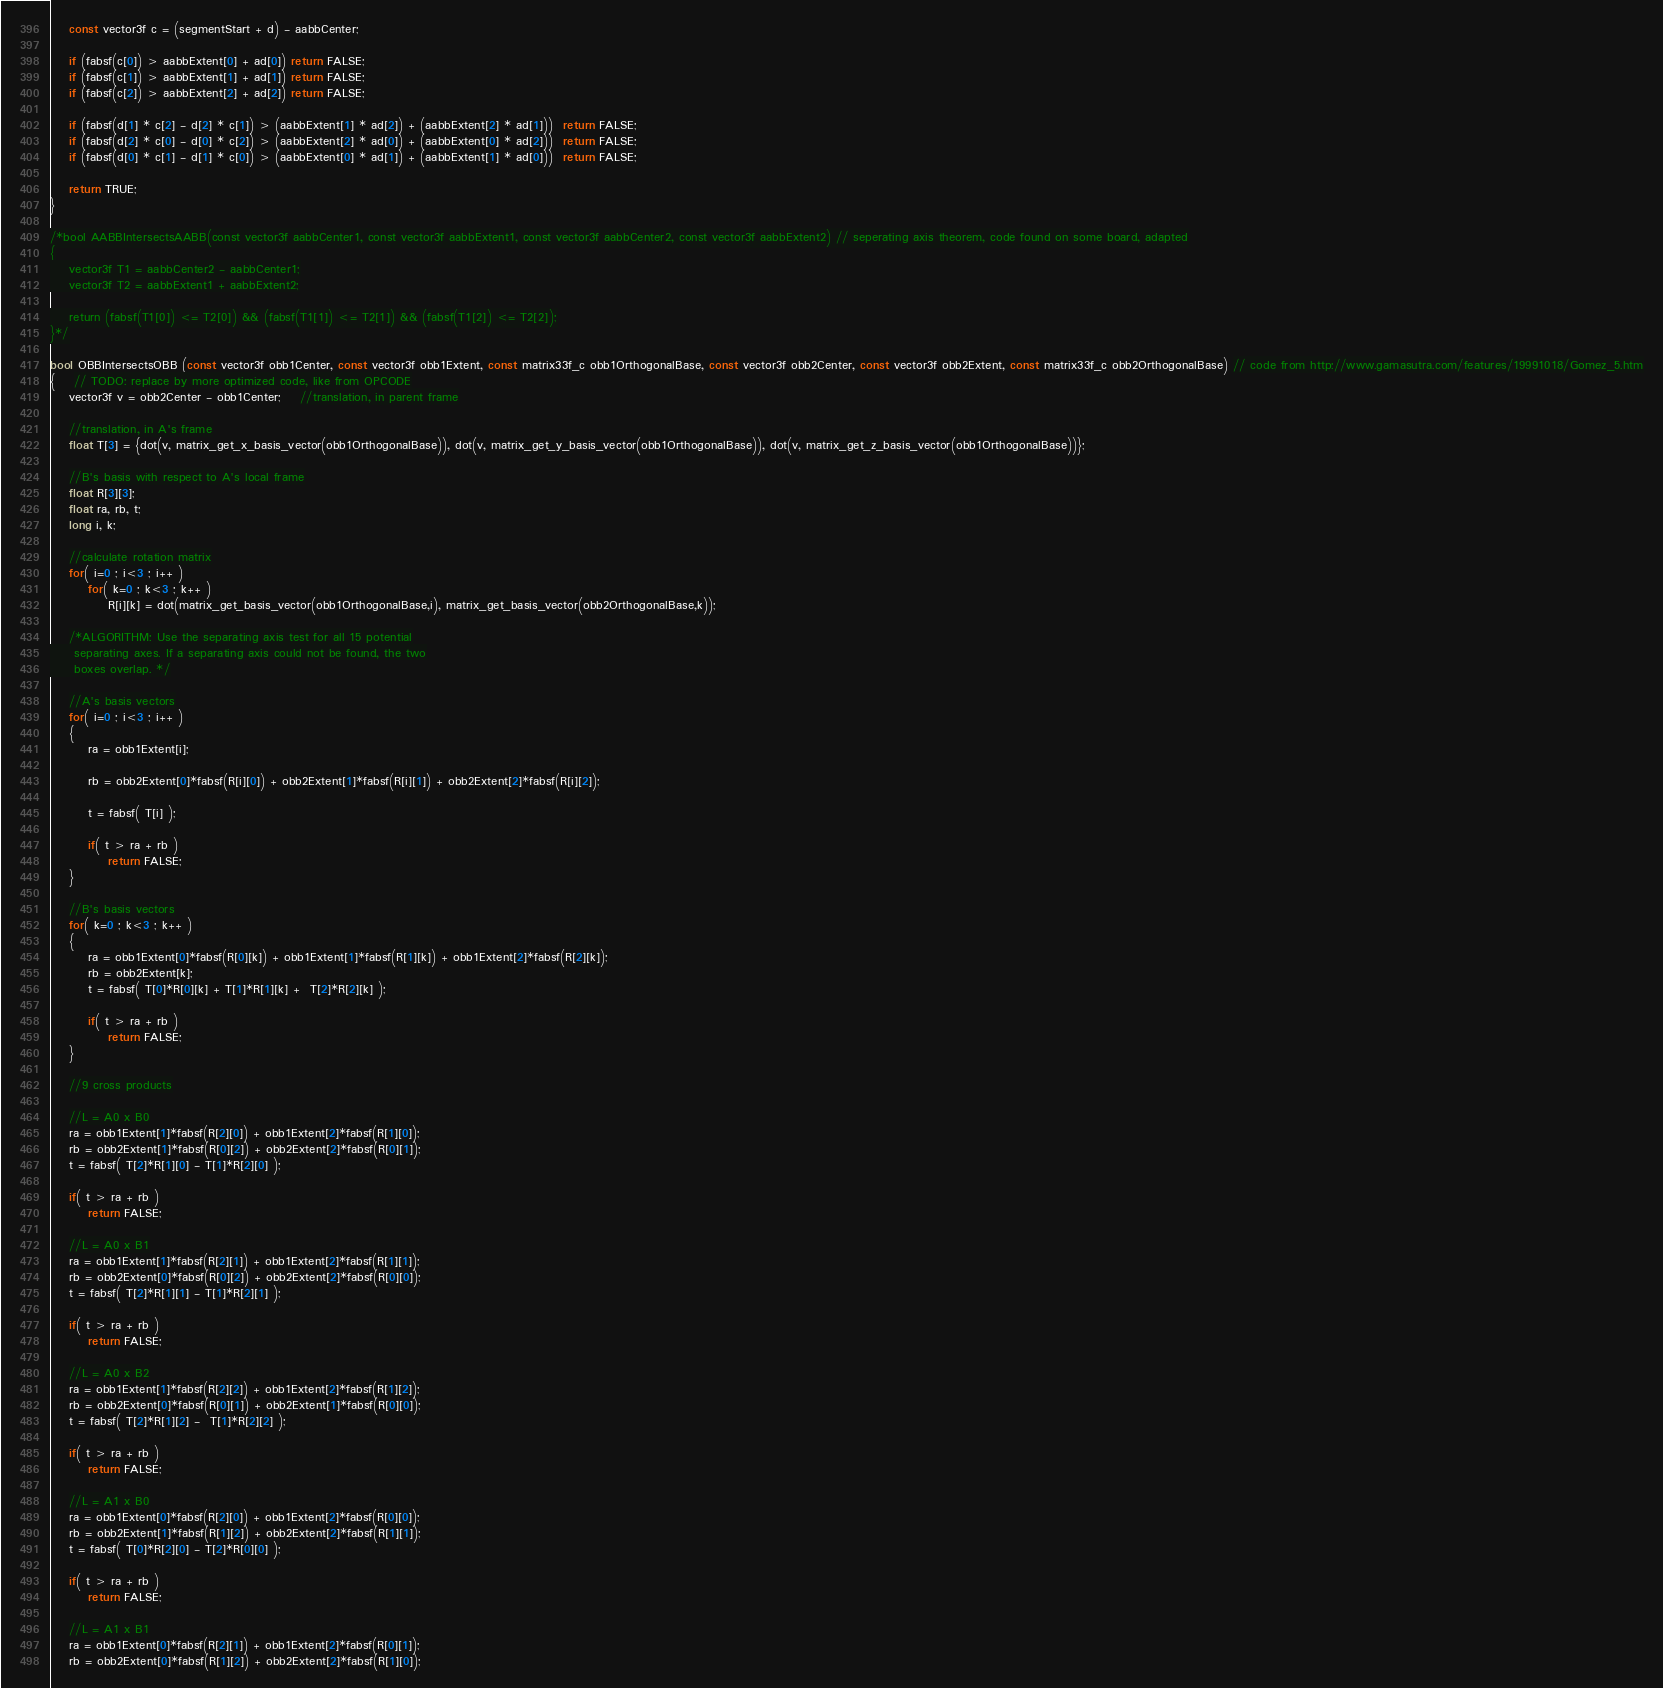<code> <loc_0><loc_0><loc_500><loc_500><_ObjectiveC_>	const vector3f c = (segmentStart + d) - aabbCenter;

    if (fabsf(c[0]) > aabbExtent[0] + ad[0]) return FALSE;
    if (fabsf(c[1]) > aabbExtent[1] + ad[1]) return FALSE;
    if (fabsf(c[2]) > aabbExtent[2] + ad[2]) return FALSE;

    if (fabsf(d[1] * c[2] - d[2] * c[1]) > (aabbExtent[1] * ad[2]) + (aabbExtent[2] * ad[1]))  return FALSE;
    if (fabsf(d[2] * c[0] - d[0] * c[2]) > (aabbExtent[2] * ad[0]) + (aabbExtent[0] * ad[2]))  return FALSE;
    if (fabsf(d[0] * c[1] - d[1] * c[0]) > (aabbExtent[0] * ad[1]) + (aabbExtent[1] * ad[0]))  return FALSE;

    return TRUE;
}

/*bool AABBIntersectsAABB(const vector3f aabbCenter1, const vector3f aabbExtent1, const vector3f aabbCenter2, const vector3f aabbExtent2) // seperating axis theorem, code found on some board, adapted
{
	vector3f T1 = aabbCenter2 - aabbCenter1;
	vector3f T2 = aabbExtent1 + aabbExtent2;

	return (fabsf(T1[0]) <= T2[0]) && (fabsf(T1[1]) <= T2[1]) && (fabsf(T1[2]) <= T2[2]);
}*/

bool OBBIntersectsOBB (const vector3f obb1Center, const vector3f obb1Extent, const matrix33f_c obb1OrthogonalBase, const vector3f obb2Center, const vector3f obb2Extent, const matrix33f_c obb2OrthogonalBase) // code from http://www.gamasutra.com/features/19991018/Gomez_5.htm
{	// TODO: replace by more optimized code, like from OPCODE
	vector3f v = obb2Center - obb1Center; 	//translation, in parent frame

	//translation, in A's frame
	float T[3] = {dot(v, matrix_get_x_basis_vector(obb1OrthogonalBase)), dot(v, matrix_get_y_basis_vector(obb1OrthogonalBase)), dot(v, matrix_get_z_basis_vector(obb1OrthogonalBase))};

	//B's basis with respect to A's local frame
	float R[3][3];
	float ra, rb, t;
	long i, k;

	//calculate rotation matrix
	for( i=0 ; i<3 ; i++ )
		for( k=0 ; k<3 ; k++ )
			R[i][k] = dot(matrix_get_basis_vector(obb1OrthogonalBase,i), matrix_get_basis_vector(obb2OrthogonalBase,k));

	/*ALGORITHM: Use the separating axis test for all 15 potential
	 separating axes. If a separating axis could not be found, the two
	 boxes overlap. */

	//A's basis vectors
	for( i=0 ; i<3 ; i++ )
	{
		ra = obb1Extent[i];

		rb = obb2Extent[0]*fabsf(R[i][0]) + obb2Extent[1]*fabsf(R[i][1]) + obb2Extent[2]*fabsf(R[i][2]);

		t = fabsf( T[i] );

		if( t > ra + rb )
			return FALSE;
	}

	//B's basis vectors
	for( k=0 ; k<3 ; k++ )
	{
		ra = obb1Extent[0]*fabsf(R[0][k]) + obb1Extent[1]*fabsf(R[1][k]) + obb1Extent[2]*fabsf(R[2][k]);
		rb = obb2Extent[k];
		t = fabsf( T[0]*R[0][k] + T[1]*R[1][k] +  T[2]*R[2][k] );

		if( t > ra + rb )
			return FALSE;
	}

	//9 cross products

	//L = A0 x B0
	ra = obb1Extent[1]*fabsf(R[2][0]) + obb1Extent[2]*fabsf(R[1][0]);
	rb = obb2Extent[1]*fabsf(R[0][2]) + obb2Extent[2]*fabsf(R[0][1]);
	t = fabsf( T[2]*R[1][0] - T[1]*R[2][0] );

	if( t > ra + rb )
		return FALSE;

	//L = A0 x B1
	ra = obb1Extent[1]*fabsf(R[2][1]) + obb1Extent[2]*fabsf(R[1][1]);
	rb = obb2Extent[0]*fabsf(R[0][2]) + obb2Extent[2]*fabsf(R[0][0]);
	t = fabsf( T[2]*R[1][1] - T[1]*R[2][1] );

	if( t > ra + rb )
		return FALSE;

	//L = A0 x B2
	ra = obb1Extent[1]*fabsf(R[2][2]) + obb1Extent[2]*fabsf(R[1][2]);
	rb = obb2Extent[0]*fabsf(R[0][1]) + obb2Extent[1]*fabsf(R[0][0]);
	t = fabsf( T[2]*R[1][2] -  T[1]*R[2][2] );

	if( t > ra + rb )
		return FALSE;

	//L = A1 x B0
	ra = obb1Extent[0]*fabsf(R[2][0]) + obb1Extent[2]*fabsf(R[0][0]);
	rb = obb2Extent[1]*fabsf(R[1][2]) + obb2Extent[2]*fabsf(R[1][1]);
	t = fabsf( T[0]*R[2][0] - T[2]*R[0][0] );

	if( t > ra + rb )
		return FALSE;

	//L = A1 x B1
	ra = obb1Extent[0]*fabsf(R[2][1]) + obb1Extent[2]*fabsf(R[0][1]);
	rb = obb2Extent[0]*fabsf(R[1][2]) + obb2Extent[2]*fabsf(R[1][0]);</code> 